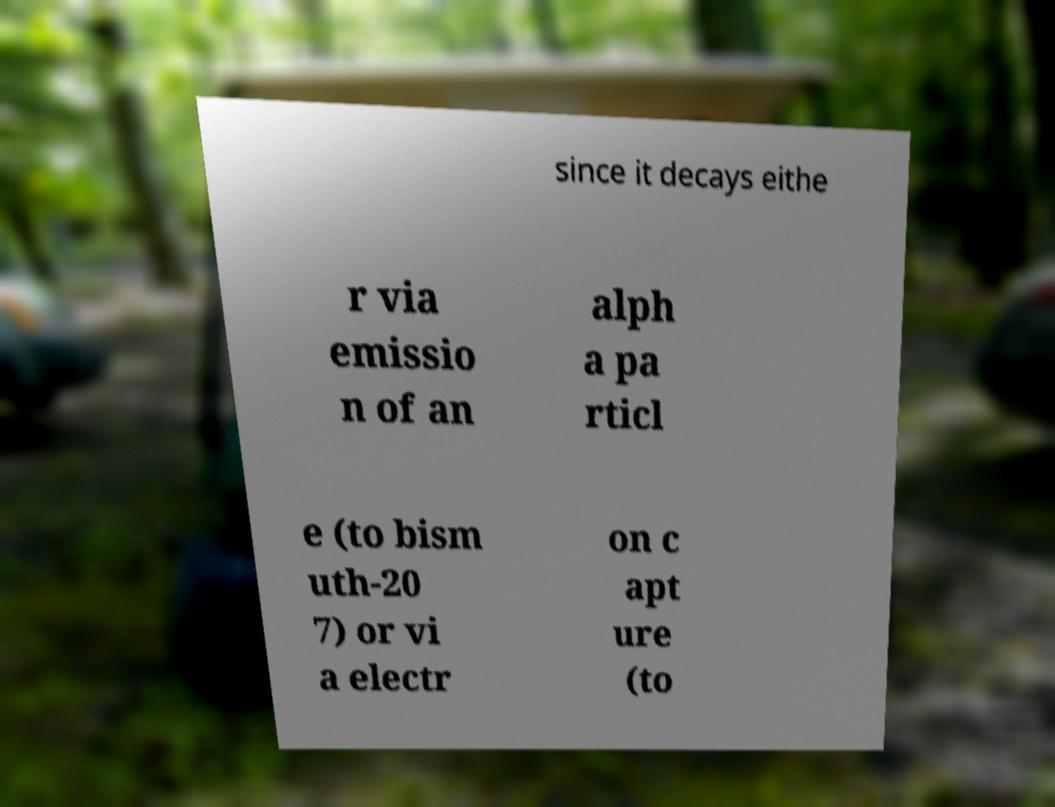What messages or text are displayed in this image? I need them in a readable, typed format. since it decays eithe r via emissio n of an alph a pa rticl e (to bism uth-20 7) or vi a electr on c apt ure (to 